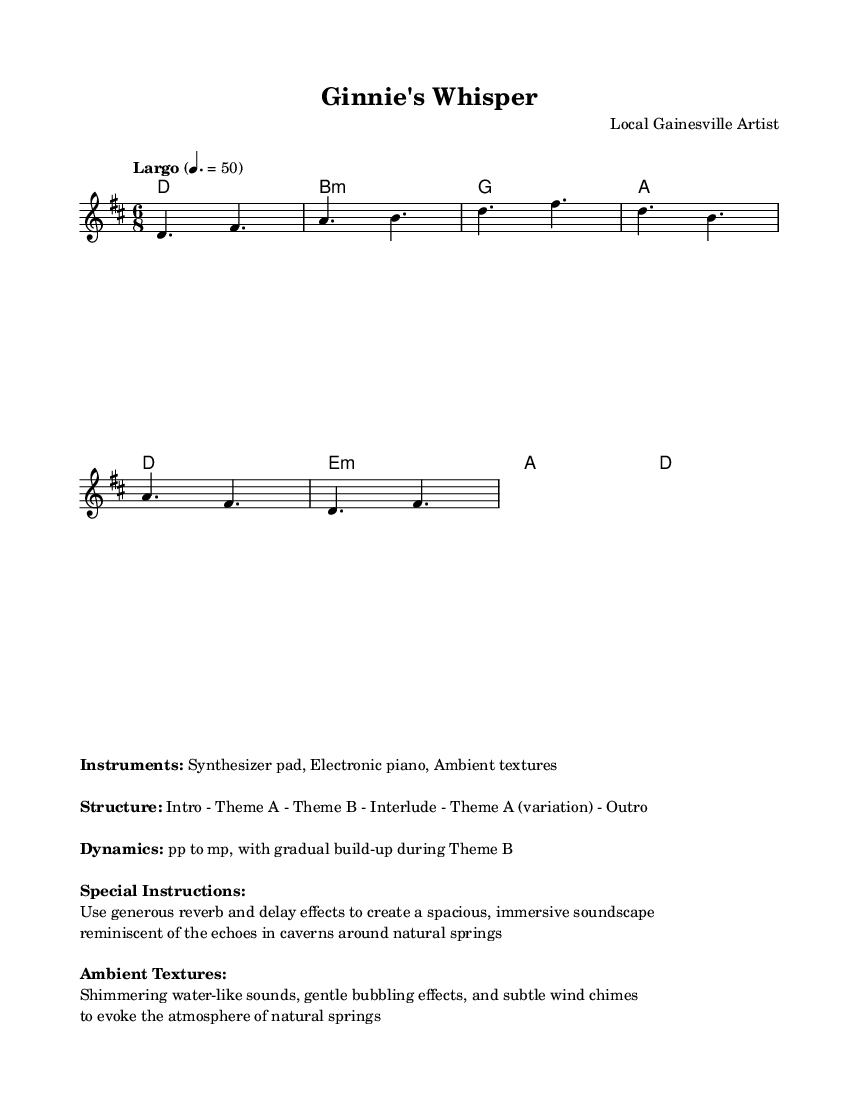What is the title of this composition? The title is presented in the header section of the sheet music. It states "Ginnie's Whisper."
Answer: Ginnie's Whisper What is the time signature of this piece? The time signature can typically be found at the beginning of the score; here it is noted as 6/8.
Answer: 6/8 What is the tempo marking for this composition? The tempo marking is found in the global context section of the music, which indicates "Largo" with a metronome marking of quarter note = 50.
Answer: Largo How many themes are mentioned in the structure? The structure section notes "Intro - Theme A - Theme B - Interlude - Theme A (variation) - Outro," which indicates there are two distinct themes.
Answer: Two What should be the dynamics during Theme B? The dynamics instruction indicates that there is a gradual build-up, starting from piano to mezzo-piano during Theme B. The terms used specifically mention "pp to mp."
Answer: pp to mp What kind of effects are recommended to be used in the composition? The special instructions suggest using "generous reverb and delay effects," which are mentioned to create an immersive soundscape.
Answer: Reverb and delay effects What does the music aim to evoke in terms of ambient textures? The ambient textures explicitly mention "shimmering water-like sounds, gentle bubbling effects, and subtle wind chimes," which are intended to replicate the atmosphere of natural springs.
Answer: Water-like sounds, bubbling effects, and wind chimes 